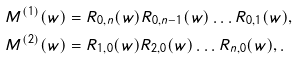Convert formula to latex. <formula><loc_0><loc_0><loc_500><loc_500>& M ^ { ( 1 ) } ( w ) = R _ { 0 , n } ( w ) R _ { 0 , n - 1 } ( w ) \dots R _ { 0 , 1 } ( w ) , \\ & M ^ { ( 2 ) } ( w ) = R _ { 1 , 0 } ( w ) R _ { 2 , 0 } ( w ) \dots R _ { n , 0 } ( w ) , .</formula> 